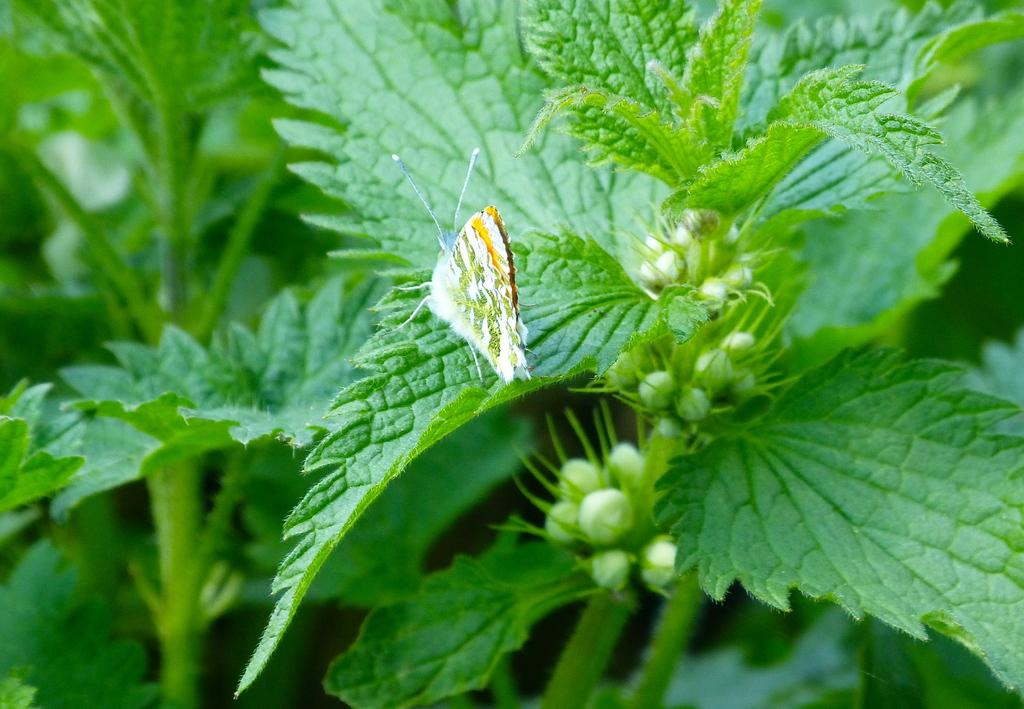What is the main subject of the image? There is a butterfly in the image. Where is the butterfly located? The butterfly is on a leaf. What is the leaf part of? The leaf is part of a plant. What is the state of the plant's growth? The plant has buds. What type of hydrant can be seen in the image? There is no hydrant present in the image. How does the butterfly use the stick in the image? There is no stick present in the image. 